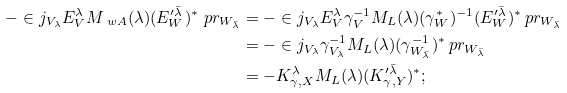Convert formula to latex. <formula><loc_0><loc_0><loc_500><loc_500>- \in j _ { V _ { \lambda } } E ^ { \lambda } _ { V } M _ { \ w A } ( \lambda ) ( E ^ { \prime \bar { \lambda } } _ { W } ) ^ { * } \ p r _ { W _ { \bar { \lambda } } } & = - \in j _ { V _ { \lambda } } E ^ { \lambda } _ { V } \gamma _ { V } ^ { - 1 } M _ { L } ( \lambda ) ( \gamma _ { W } ^ { * } ) ^ { - 1 } ( E ^ { \prime \bar { \lambda } } _ { W } ) ^ { * } \ p r _ { W _ { \bar { \lambda } } } \\ & = - \in j _ { V _ { \lambda } } \gamma _ { V _ { \lambda } } ^ { - 1 } M _ { L } ( \lambda ) ( \gamma _ { W _ { \bar { \lambda } } } ^ { - 1 } ) ^ { * } \ p r _ { W _ { \bar { \lambda } } } \\ & = - K ^ { \lambda } _ { \gamma , X } M _ { L } ( \lambda ) ( K ^ { \prime \bar { \lambda } } _ { \gamma , Y } ) ^ { * } ;</formula> 